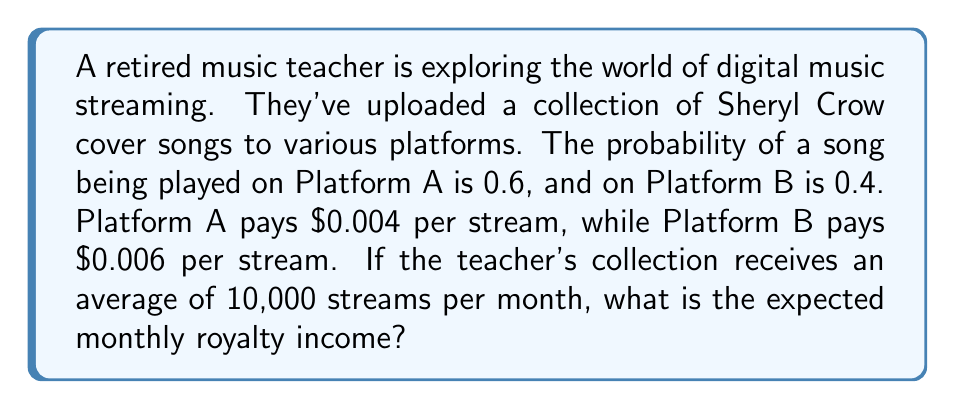Provide a solution to this math problem. Let's approach this step-by-step using probability theory and expected value:

1) Define the random variable:
   Let $X$ be the royalty earned from a single stream.

2) Determine the probability distribution:
   $P(X = 0.004) = 0.6$ (probability of being played on Platform A)
   $P(X = 0.006) = 0.4$ (probability of being played on Platform B)

3) Calculate the expected value of $X$:
   $$E(X) = \sum_{i} x_i \cdot P(X = x_i)$$
   $$E(X) = 0.004 \cdot 0.6 + 0.006 \cdot 0.4$$
   $$E(X) = 0.0024 + 0.0024 = 0.0048$$

4) The expected royalty per stream is $0.0048.

5) For 10,000 streams per month, the expected monthly royalty is:
   $$10,000 \cdot E(X) = 10,000 \cdot 0.0048 = 48$$

Therefore, the expected monthly royalty income is $48.
Answer: $48 